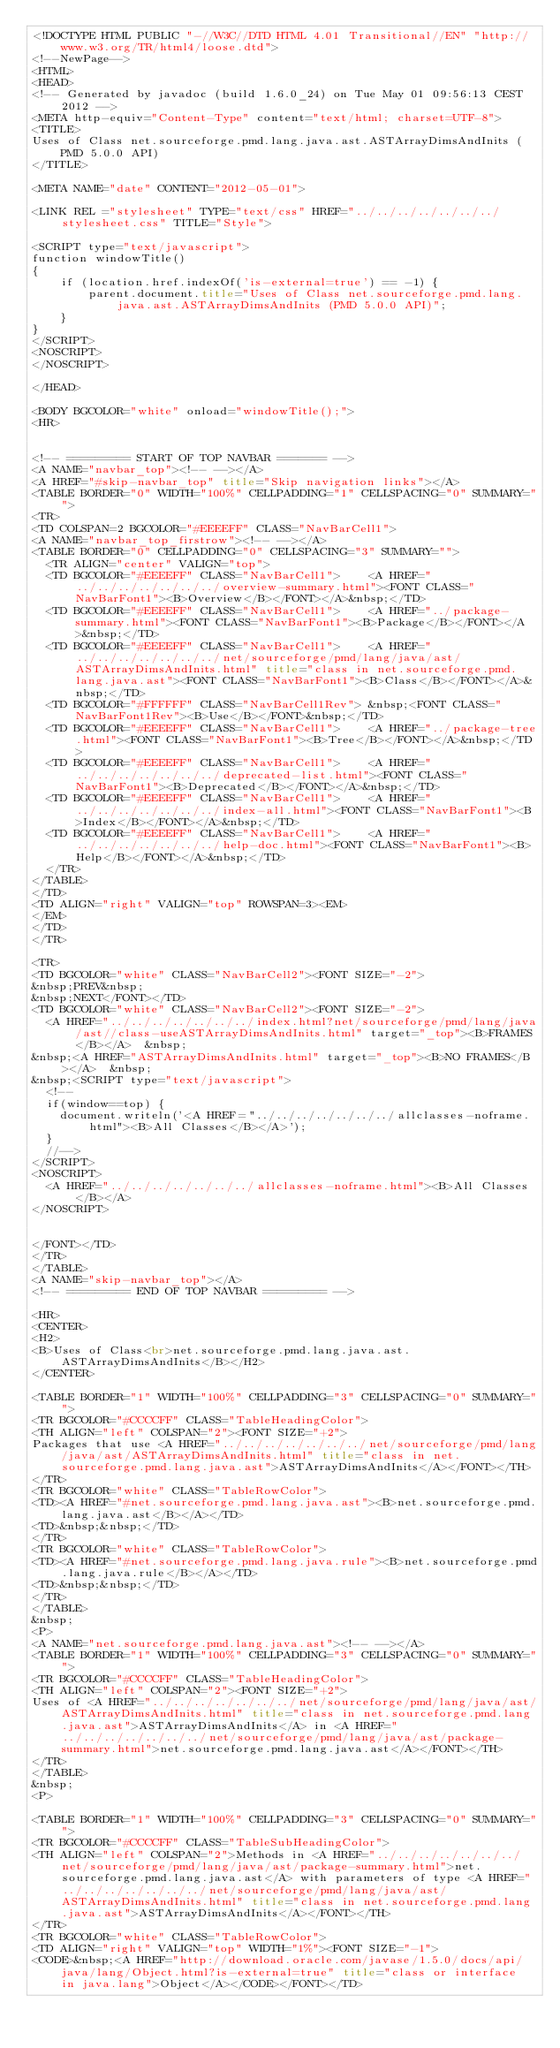<code> <loc_0><loc_0><loc_500><loc_500><_HTML_><!DOCTYPE HTML PUBLIC "-//W3C//DTD HTML 4.01 Transitional//EN" "http://www.w3.org/TR/html4/loose.dtd">
<!--NewPage-->
<HTML>
<HEAD>
<!-- Generated by javadoc (build 1.6.0_24) on Tue May 01 09:56:13 CEST 2012 -->
<META http-equiv="Content-Type" content="text/html; charset=UTF-8">
<TITLE>
Uses of Class net.sourceforge.pmd.lang.java.ast.ASTArrayDimsAndInits (PMD 5.0.0 API)
</TITLE>

<META NAME="date" CONTENT="2012-05-01">

<LINK REL ="stylesheet" TYPE="text/css" HREF="../../../../../../../stylesheet.css" TITLE="Style">

<SCRIPT type="text/javascript">
function windowTitle()
{
    if (location.href.indexOf('is-external=true') == -1) {
        parent.document.title="Uses of Class net.sourceforge.pmd.lang.java.ast.ASTArrayDimsAndInits (PMD 5.0.0 API)";
    }
}
</SCRIPT>
<NOSCRIPT>
</NOSCRIPT>

</HEAD>

<BODY BGCOLOR="white" onload="windowTitle();">
<HR>


<!-- ========= START OF TOP NAVBAR ======= -->
<A NAME="navbar_top"><!-- --></A>
<A HREF="#skip-navbar_top" title="Skip navigation links"></A>
<TABLE BORDER="0" WIDTH="100%" CELLPADDING="1" CELLSPACING="0" SUMMARY="">
<TR>
<TD COLSPAN=2 BGCOLOR="#EEEEFF" CLASS="NavBarCell1">
<A NAME="navbar_top_firstrow"><!-- --></A>
<TABLE BORDER="0" CELLPADDING="0" CELLSPACING="3" SUMMARY="">
  <TR ALIGN="center" VALIGN="top">
  <TD BGCOLOR="#EEEEFF" CLASS="NavBarCell1">    <A HREF="../../../../../../../overview-summary.html"><FONT CLASS="NavBarFont1"><B>Overview</B></FONT></A>&nbsp;</TD>
  <TD BGCOLOR="#EEEEFF" CLASS="NavBarCell1">    <A HREF="../package-summary.html"><FONT CLASS="NavBarFont1"><B>Package</B></FONT></A>&nbsp;</TD>
  <TD BGCOLOR="#EEEEFF" CLASS="NavBarCell1">    <A HREF="../../../../../../../net/sourceforge/pmd/lang/java/ast/ASTArrayDimsAndInits.html" title="class in net.sourceforge.pmd.lang.java.ast"><FONT CLASS="NavBarFont1"><B>Class</B></FONT></A>&nbsp;</TD>
  <TD BGCOLOR="#FFFFFF" CLASS="NavBarCell1Rev"> &nbsp;<FONT CLASS="NavBarFont1Rev"><B>Use</B></FONT>&nbsp;</TD>
  <TD BGCOLOR="#EEEEFF" CLASS="NavBarCell1">    <A HREF="../package-tree.html"><FONT CLASS="NavBarFont1"><B>Tree</B></FONT></A>&nbsp;</TD>
  <TD BGCOLOR="#EEEEFF" CLASS="NavBarCell1">    <A HREF="../../../../../../../deprecated-list.html"><FONT CLASS="NavBarFont1"><B>Deprecated</B></FONT></A>&nbsp;</TD>
  <TD BGCOLOR="#EEEEFF" CLASS="NavBarCell1">    <A HREF="../../../../../../../index-all.html"><FONT CLASS="NavBarFont1"><B>Index</B></FONT></A>&nbsp;</TD>
  <TD BGCOLOR="#EEEEFF" CLASS="NavBarCell1">    <A HREF="../../../../../../../help-doc.html"><FONT CLASS="NavBarFont1"><B>Help</B></FONT></A>&nbsp;</TD>
  </TR>
</TABLE>
</TD>
<TD ALIGN="right" VALIGN="top" ROWSPAN=3><EM>
</EM>
</TD>
</TR>

<TR>
<TD BGCOLOR="white" CLASS="NavBarCell2"><FONT SIZE="-2">
&nbsp;PREV&nbsp;
&nbsp;NEXT</FONT></TD>
<TD BGCOLOR="white" CLASS="NavBarCell2"><FONT SIZE="-2">
  <A HREF="../../../../../../../index.html?net/sourceforge/pmd/lang/java/ast//class-useASTArrayDimsAndInits.html" target="_top"><B>FRAMES</B></A>  &nbsp;
&nbsp;<A HREF="ASTArrayDimsAndInits.html" target="_top"><B>NO FRAMES</B></A>  &nbsp;
&nbsp;<SCRIPT type="text/javascript">
  <!--
  if(window==top) {
    document.writeln('<A HREF="../../../../../../../allclasses-noframe.html"><B>All Classes</B></A>');
  }
  //-->
</SCRIPT>
<NOSCRIPT>
  <A HREF="../../../../../../../allclasses-noframe.html"><B>All Classes</B></A>
</NOSCRIPT>


</FONT></TD>
</TR>
</TABLE>
<A NAME="skip-navbar_top"></A>
<!-- ========= END OF TOP NAVBAR ========= -->

<HR>
<CENTER>
<H2>
<B>Uses of Class<br>net.sourceforge.pmd.lang.java.ast.ASTArrayDimsAndInits</B></H2>
</CENTER>

<TABLE BORDER="1" WIDTH="100%" CELLPADDING="3" CELLSPACING="0" SUMMARY="">
<TR BGCOLOR="#CCCCFF" CLASS="TableHeadingColor">
<TH ALIGN="left" COLSPAN="2"><FONT SIZE="+2">
Packages that use <A HREF="../../../../../../../net/sourceforge/pmd/lang/java/ast/ASTArrayDimsAndInits.html" title="class in net.sourceforge.pmd.lang.java.ast">ASTArrayDimsAndInits</A></FONT></TH>
</TR>
<TR BGCOLOR="white" CLASS="TableRowColor">
<TD><A HREF="#net.sourceforge.pmd.lang.java.ast"><B>net.sourceforge.pmd.lang.java.ast</B></A></TD>
<TD>&nbsp;&nbsp;</TD>
</TR>
<TR BGCOLOR="white" CLASS="TableRowColor">
<TD><A HREF="#net.sourceforge.pmd.lang.java.rule"><B>net.sourceforge.pmd.lang.java.rule</B></A></TD>
<TD>&nbsp;&nbsp;</TD>
</TR>
</TABLE>
&nbsp;
<P>
<A NAME="net.sourceforge.pmd.lang.java.ast"><!-- --></A>
<TABLE BORDER="1" WIDTH="100%" CELLPADDING="3" CELLSPACING="0" SUMMARY="">
<TR BGCOLOR="#CCCCFF" CLASS="TableHeadingColor">
<TH ALIGN="left" COLSPAN="2"><FONT SIZE="+2">
Uses of <A HREF="../../../../../../../net/sourceforge/pmd/lang/java/ast/ASTArrayDimsAndInits.html" title="class in net.sourceforge.pmd.lang.java.ast">ASTArrayDimsAndInits</A> in <A HREF="../../../../../../../net/sourceforge/pmd/lang/java/ast/package-summary.html">net.sourceforge.pmd.lang.java.ast</A></FONT></TH>
</TR>
</TABLE>
&nbsp;
<P>

<TABLE BORDER="1" WIDTH="100%" CELLPADDING="3" CELLSPACING="0" SUMMARY="">
<TR BGCOLOR="#CCCCFF" CLASS="TableSubHeadingColor">
<TH ALIGN="left" COLSPAN="2">Methods in <A HREF="../../../../../../../net/sourceforge/pmd/lang/java/ast/package-summary.html">net.sourceforge.pmd.lang.java.ast</A> with parameters of type <A HREF="../../../../../../../net/sourceforge/pmd/lang/java/ast/ASTArrayDimsAndInits.html" title="class in net.sourceforge.pmd.lang.java.ast">ASTArrayDimsAndInits</A></FONT></TH>
</TR>
<TR BGCOLOR="white" CLASS="TableRowColor">
<TD ALIGN="right" VALIGN="top" WIDTH="1%"><FONT SIZE="-1">
<CODE>&nbsp;<A HREF="http://download.oracle.com/javase/1.5.0/docs/api/java/lang/Object.html?is-external=true" title="class or interface in java.lang">Object</A></CODE></FONT></TD></code> 